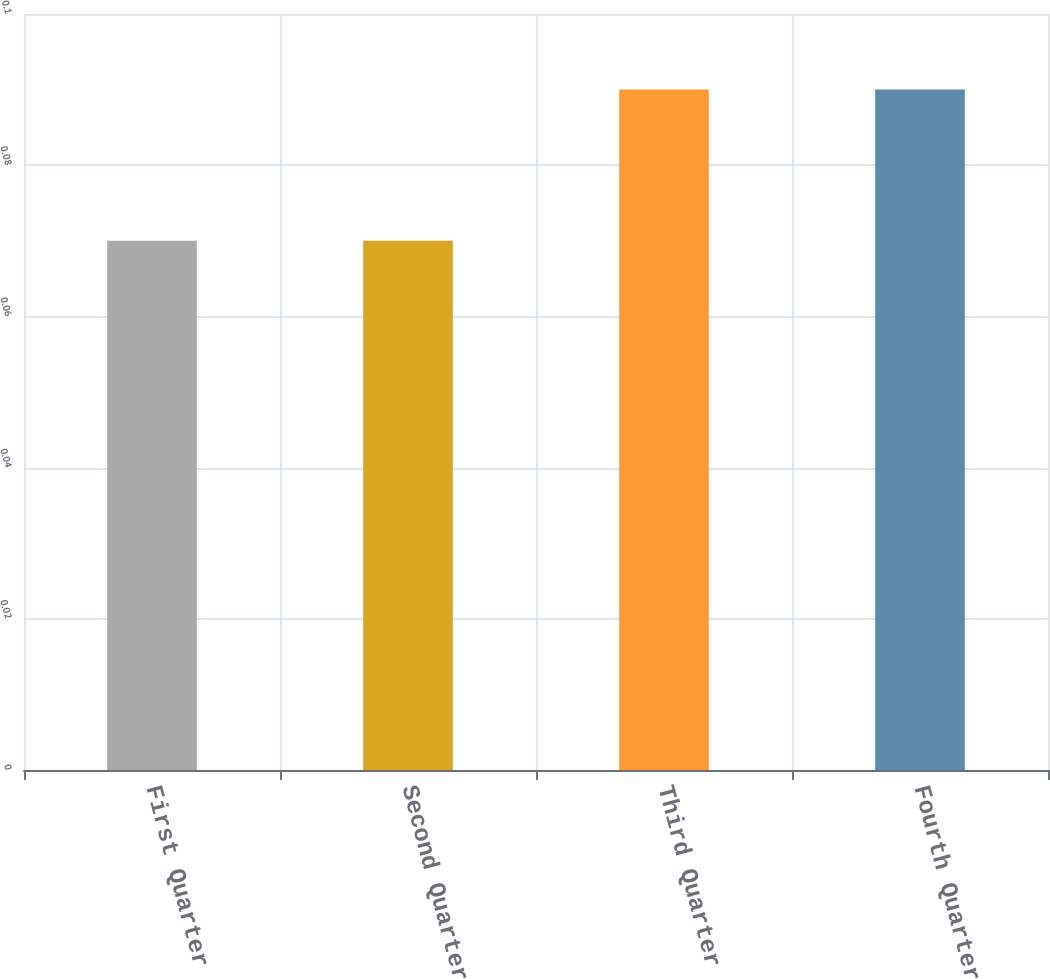Convert chart. <chart><loc_0><loc_0><loc_500><loc_500><bar_chart><fcel>First Quarter<fcel>Second Quarter<fcel>Third Quarter<fcel>Fourth Quarter<nl><fcel>0.07<fcel>0.07<fcel>0.09<fcel>0.09<nl></chart> 